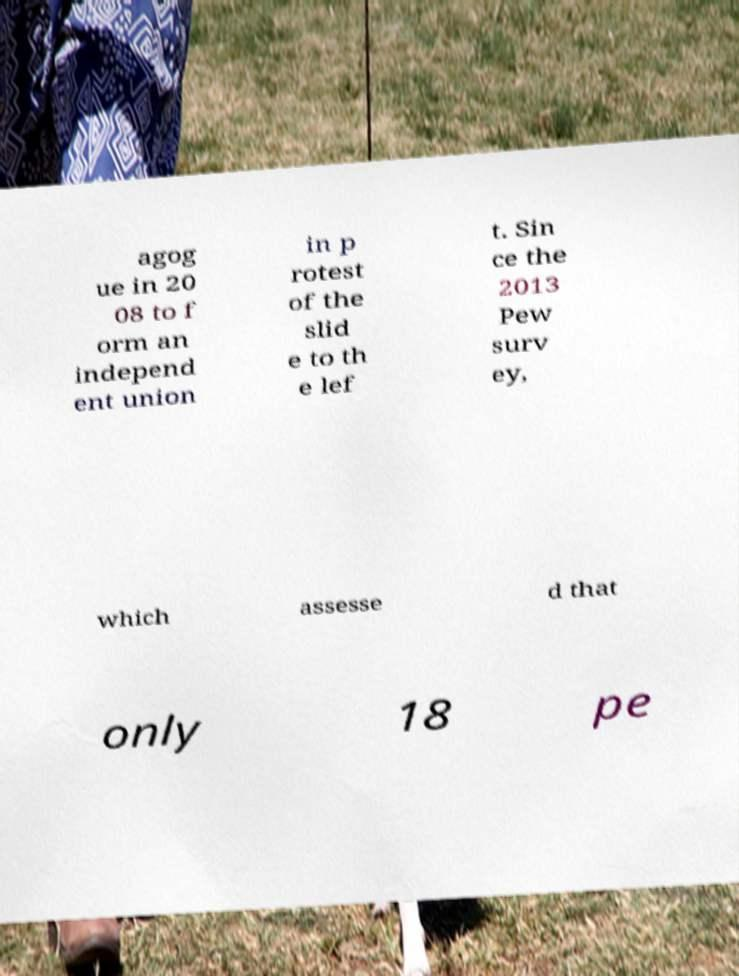What messages or text are displayed in this image? I need them in a readable, typed format. agog ue in 20 08 to f orm an independ ent union in p rotest of the slid e to th e lef t. Sin ce the 2013 Pew surv ey, which assesse d that only 18 pe 